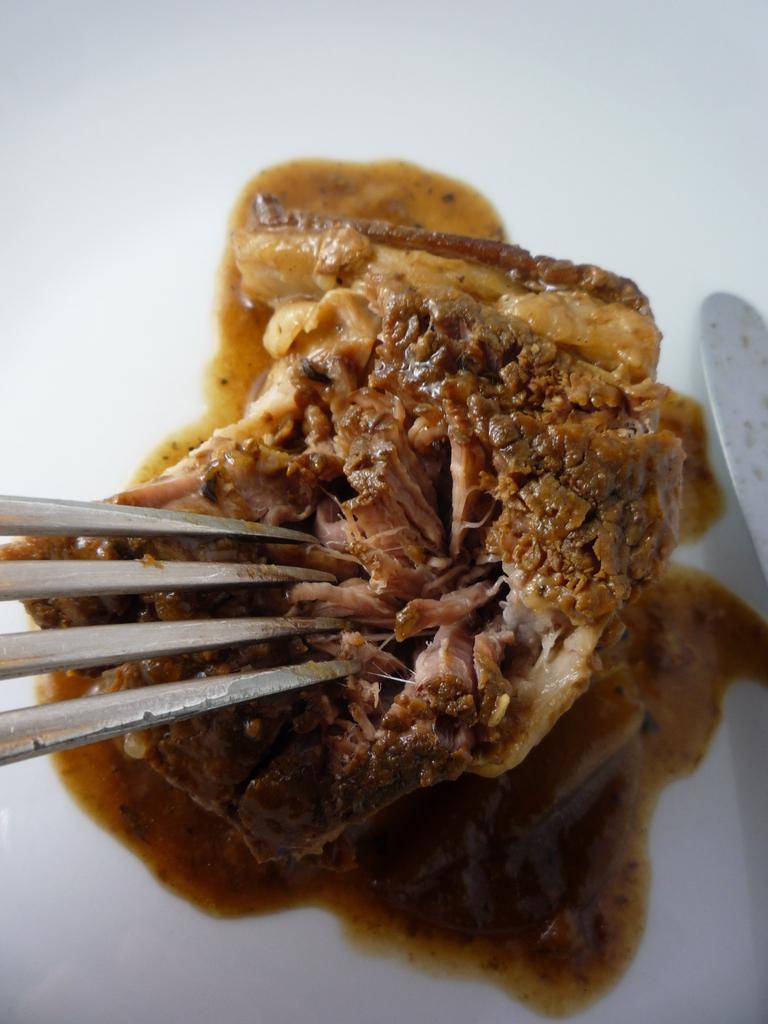What is the main subject of the image? There is a food item in the image. What utensil is present with the food item? The food item is accompanied by a fork. Can you describe the other object beside the food item and fork? There is another object beside the food item and fork, but its description is not provided in the facts. How many toys can be seen in the image? There is no mention of toys in the image, so it is not possible to determine their presence or quantity. 